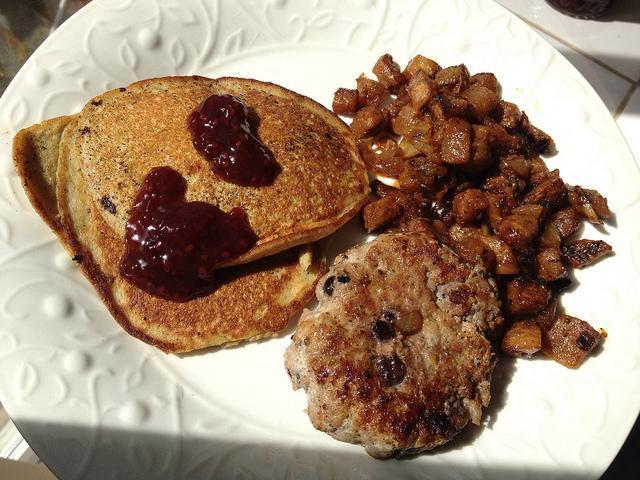How many suitcases is the man pulling?
Give a very brief answer. 0. 